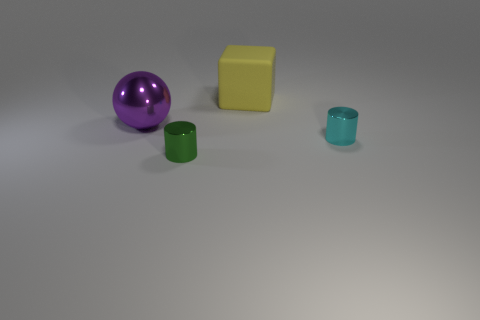Add 2 tiny green objects. How many objects exist? 6 Add 3 large objects. How many large objects are left? 5 Add 4 large cyan metallic cylinders. How many large cyan metallic cylinders exist? 4 Subtract all cyan cylinders. How many cylinders are left? 1 Subtract 0 cyan cubes. How many objects are left? 4 Subtract all blocks. How many objects are left? 3 Subtract 1 balls. How many balls are left? 0 Subtract all purple cylinders. Subtract all blue spheres. How many cylinders are left? 2 Subtract all yellow spheres. How many yellow cylinders are left? 0 Subtract all red blocks. Subtract all large purple shiny objects. How many objects are left? 3 